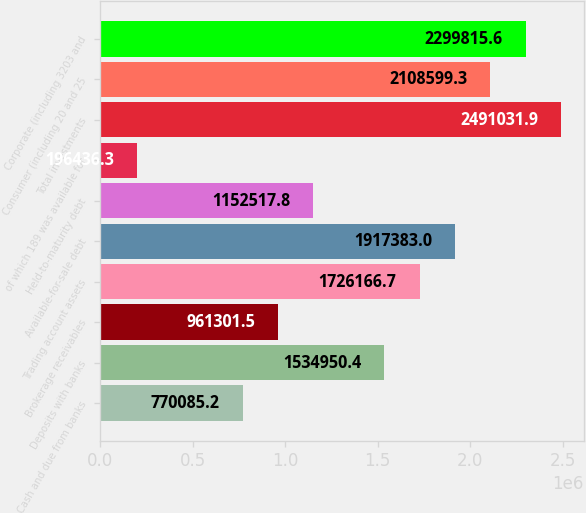<chart> <loc_0><loc_0><loc_500><loc_500><bar_chart><fcel>Cash and due from banks<fcel>Deposits with banks<fcel>Brokerage receivables<fcel>Trading account assets<fcel>Available-for-sale debt<fcel>Held-to-maturity debt<fcel>of which 189 was available for<fcel>Total investments<fcel>Consumer (including 20 and 25<fcel>Corporate (including 3203 and<nl><fcel>770085<fcel>1.53495e+06<fcel>961302<fcel>1.72617e+06<fcel>1.91738e+06<fcel>1.15252e+06<fcel>196436<fcel>2.49103e+06<fcel>2.1086e+06<fcel>2.29982e+06<nl></chart> 